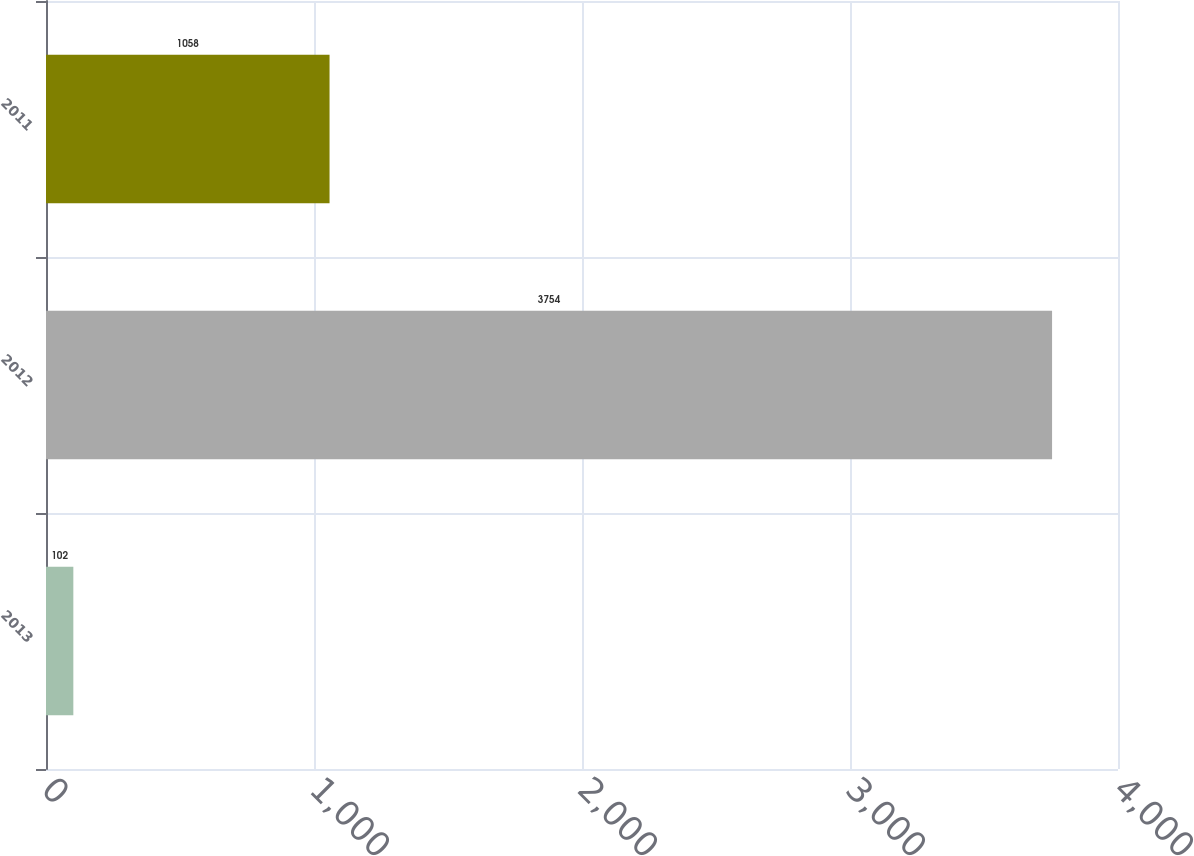Convert chart to OTSL. <chart><loc_0><loc_0><loc_500><loc_500><bar_chart><fcel>2013<fcel>2012<fcel>2011<nl><fcel>102<fcel>3754<fcel>1058<nl></chart> 